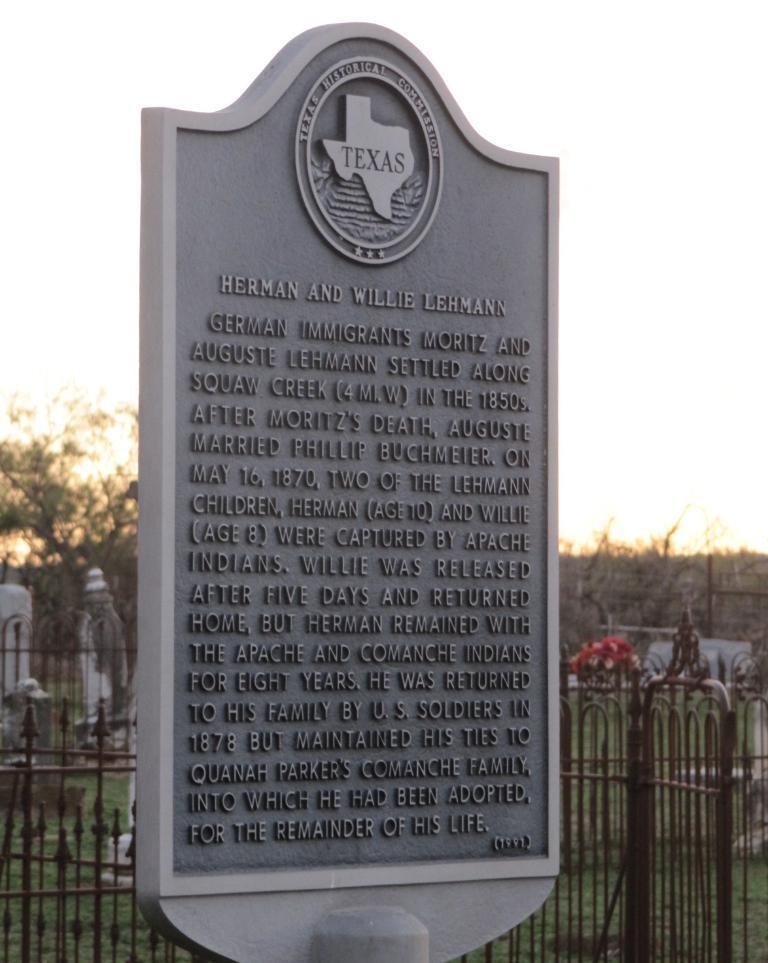In one or two sentences, can you explain what this image depicts? In the image we can see a memorial, on it there is a text, this is a fence, grass, tree and a sky. 